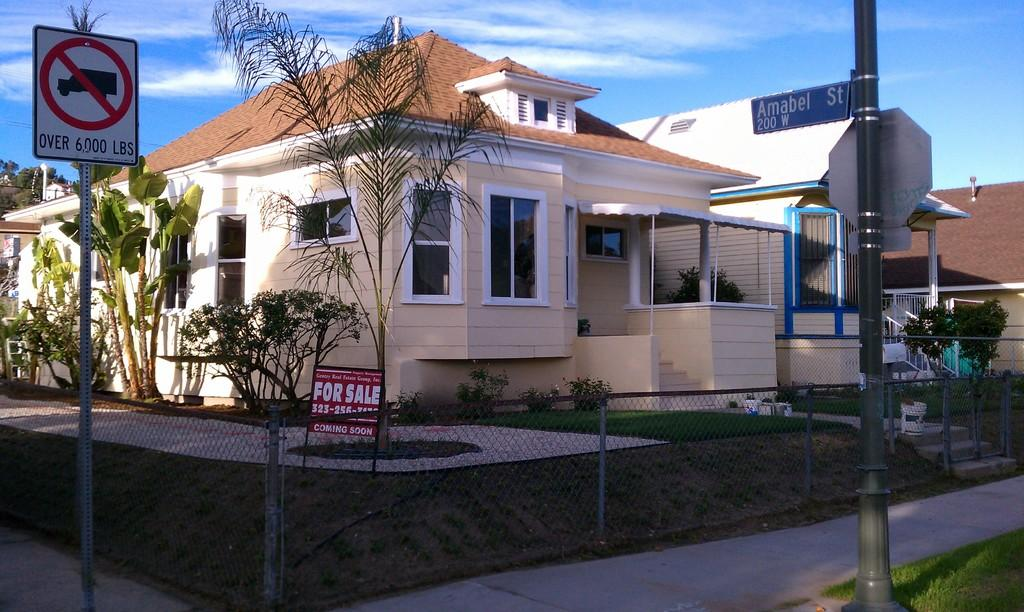Provide a one-sentence caption for the provided image. A House is for sale on the corner of the street. 